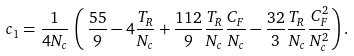<formula> <loc_0><loc_0><loc_500><loc_500>c _ { 1 } = \frac { 1 } { 4 N _ { c } } \, \left ( \, \frac { 5 5 } { 9 } - 4 \frac { T _ { R } } { N _ { c } } + \frac { 1 1 2 } { 9 } \frac { T _ { R } } { N _ { c } } \frac { C _ { F } } { N _ { c } } - \frac { 3 2 } { 3 } \frac { T _ { R } } { N _ { c } } \frac { C _ { F } ^ { 2 } } { N _ { c } ^ { 2 } } \right ) .</formula> 